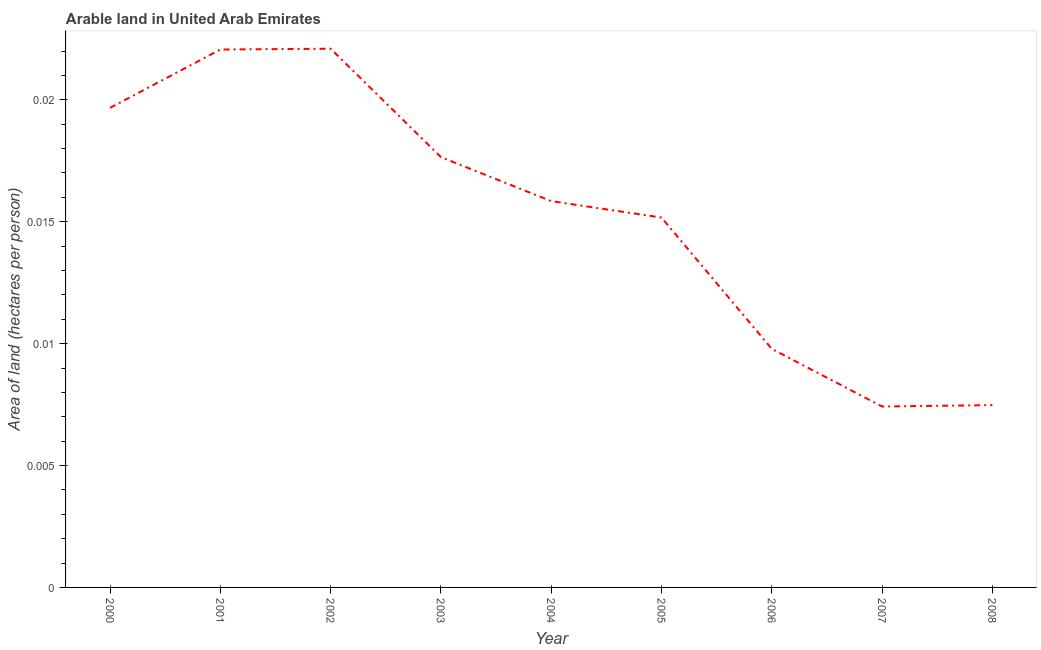What is the area of arable land in 2004?
Provide a short and direct response. 0.02. Across all years, what is the maximum area of arable land?
Make the answer very short. 0.02. Across all years, what is the minimum area of arable land?
Offer a very short reply. 0.01. In which year was the area of arable land maximum?
Give a very brief answer. 2002. In which year was the area of arable land minimum?
Your answer should be very brief. 2007. What is the sum of the area of arable land?
Your answer should be very brief. 0.14. What is the difference between the area of arable land in 2004 and 2005?
Your response must be concise. 0. What is the average area of arable land per year?
Make the answer very short. 0.02. What is the median area of arable land?
Offer a terse response. 0.02. Do a majority of the years between 2006 and 2005 (inclusive) have area of arable land greater than 0.004 hectares per person?
Make the answer very short. No. What is the ratio of the area of arable land in 2002 to that in 2005?
Your answer should be compact. 1.46. Is the area of arable land in 2001 less than that in 2007?
Your answer should be compact. No. Is the difference between the area of arable land in 2001 and 2004 greater than the difference between any two years?
Provide a short and direct response. No. What is the difference between the highest and the second highest area of arable land?
Make the answer very short. 3.310999395150088e-5. What is the difference between the highest and the lowest area of arable land?
Give a very brief answer. 0.01. In how many years, is the area of arable land greater than the average area of arable land taken over all years?
Your answer should be compact. 5. How many years are there in the graph?
Give a very brief answer. 9. What is the difference between two consecutive major ticks on the Y-axis?
Make the answer very short. 0.01. Are the values on the major ticks of Y-axis written in scientific E-notation?
Ensure brevity in your answer.  No. Does the graph contain any zero values?
Keep it short and to the point. No. What is the title of the graph?
Provide a succinct answer. Arable land in United Arab Emirates. What is the label or title of the Y-axis?
Provide a succinct answer. Area of land (hectares per person). What is the Area of land (hectares per person) in 2000?
Offer a terse response. 0.02. What is the Area of land (hectares per person) of 2001?
Make the answer very short. 0.02. What is the Area of land (hectares per person) of 2002?
Your answer should be compact. 0.02. What is the Area of land (hectares per person) of 2003?
Your response must be concise. 0.02. What is the Area of land (hectares per person) in 2004?
Your response must be concise. 0.02. What is the Area of land (hectares per person) of 2005?
Provide a succinct answer. 0.02. What is the Area of land (hectares per person) of 2006?
Your response must be concise. 0.01. What is the Area of land (hectares per person) in 2007?
Provide a short and direct response. 0.01. What is the Area of land (hectares per person) of 2008?
Provide a short and direct response. 0.01. What is the difference between the Area of land (hectares per person) in 2000 and 2001?
Provide a short and direct response. -0. What is the difference between the Area of land (hectares per person) in 2000 and 2002?
Give a very brief answer. -0. What is the difference between the Area of land (hectares per person) in 2000 and 2003?
Give a very brief answer. 0. What is the difference between the Area of land (hectares per person) in 2000 and 2004?
Your answer should be compact. 0. What is the difference between the Area of land (hectares per person) in 2000 and 2005?
Provide a short and direct response. 0. What is the difference between the Area of land (hectares per person) in 2000 and 2006?
Make the answer very short. 0.01. What is the difference between the Area of land (hectares per person) in 2000 and 2007?
Ensure brevity in your answer.  0.01. What is the difference between the Area of land (hectares per person) in 2000 and 2008?
Your answer should be very brief. 0.01. What is the difference between the Area of land (hectares per person) in 2001 and 2002?
Make the answer very short. -3e-5. What is the difference between the Area of land (hectares per person) in 2001 and 2003?
Offer a terse response. 0. What is the difference between the Area of land (hectares per person) in 2001 and 2004?
Ensure brevity in your answer.  0.01. What is the difference between the Area of land (hectares per person) in 2001 and 2005?
Your answer should be very brief. 0.01. What is the difference between the Area of land (hectares per person) in 2001 and 2006?
Provide a short and direct response. 0.01. What is the difference between the Area of land (hectares per person) in 2001 and 2007?
Your response must be concise. 0.01. What is the difference between the Area of land (hectares per person) in 2001 and 2008?
Provide a succinct answer. 0.01. What is the difference between the Area of land (hectares per person) in 2002 and 2003?
Offer a very short reply. 0. What is the difference between the Area of land (hectares per person) in 2002 and 2004?
Offer a terse response. 0.01. What is the difference between the Area of land (hectares per person) in 2002 and 2005?
Your answer should be very brief. 0.01. What is the difference between the Area of land (hectares per person) in 2002 and 2006?
Keep it short and to the point. 0.01. What is the difference between the Area of land (hectares per person) in 2002 and 2007?
Provide a succinct answer. 0.01. What is the difference between the Area of land (hectares per person) in 2002 and 2008?
Your answer should be very brief. 0.01. What is the difference between the Area of land (hectares per person) in 2003 and 2004?
Give a very brief answer. 0. What is the difference between the Area of land (hectares per person) in 2003 and 2005?
Offer a terse response. 0. What is the difference between the Area of land (hectares per person) in 2003 and 2006?
Keep it short and to the point. 0.01. What is the difference between the Area of land (hectares per person) in 2003 and 2007?
Make the answer very short. 0.01. What is the difference between the Area of land (hectares per person) in 2003 and 2008?
Provide a succinct answer. 0.01. What is the difference between the Area of land (hectares per person) in 2004 and 2005?
Keep it short and to the point. 0. What is the difference between the Area of land (hectares per person) in 2004 and 2006?
Ensure brevity in your answer.  0.01. What is the difference between the Area of land (hectares per person) in 2004 and 2007?
Provide a succinct answer. 0.01. What is the difference between the Area of land (hectares per person) in 2004 and 2008?
Your response must be concise. 0.01. What is the difference between the Area of land (hectares per person) in 2005 and 2006?
Your response must be concise. 0.01. What is the difference between the Area of land (hectares per person) in 2005 and 2007?
Make the answer very short. 0.01. What is the difference between the Area of land (hectares per person) in 2005 and 2008?
Offer a terse response. 0.01. What is the difference between the Area of land (hectares per person) in 2006 and 2007?
Your answer should be compact. 0. What is the difference between the Area of land (hectares per person) in 2006 and 2008?
Provide a short and direct response. 0. What is the difference between the Area of land (hectares per person) in 2007 and 2008?
Keep it short and to the point. -6e-5. What is the ratio of the Area of land (hectares per person) in 2000 to that in 2001?
Your answer should be very brief. 0.89. What is the ratio of the Area of land (hectares per person) in 2000 to that in 2002?
Give a very brief answer. 0.89. What is the ratio of the Area of land (hectares per person) in 2000 to that in 2003?
Provide a short and direct response. 1.11. What is the ratio of the Area of land (hectares per person) in 2000 to that in 2004?
Provide a short and direct response. 1.24. What is the ratio of the Area of land (hectares per person) in 2000 to that in 2005?
Ensure brevity in your answer.  1.3. What is the ratio of the Area of land (hectares per person) in 2000 to that in 2006?
Your answer should be compact. 2.01. What is the ratio of the Area of land (hectares per person) in 2000 to that in 2007?
Offer a very short reply. 2.65. What is the ratio of the Area of land (hectares per person) in 2000 to that in 2008?
Provide a succinct answer. 2.63. What is the ratio of the Area of land (hectares per person) in 2001 to that in 2002?
Give a very brief answer. 1. What is the ratio of the Area of land (hectares per person) in 2001 to that in 2003?
Your answer should be compact. 1.25. What is the ratio of the Area of land (hectares per person) in 2001 to that in 2004?
Your response must be concise. 1.39. What is the ratio of the Area of land (hectares per person) in 2001 to that in 2005?
Offer a very short reply. 1.45. What is the ratio of the Area of land (hectares per person) in 2001 to that in 2006?
Your response must be concise. 2.25. What is the ratio of the Area of land (hectares per person) in 2001 to that in 2007?
Your response must be concise. 2.97. What is the ratio of the Area of land (hectares per person) in 2001 to that in 2008?
Keep it short and to the point. 2.95. What is the ratio of the Area of land (hectares per person) in 2002 to that in 2003?
Your answer should be compact. 1.25. What is the ratio of the Area of land (hectares per person) in 2002 to that in 2004?
Provide a succinct answer. 1.4. What is the ratio of the Area of land (hectares per person) in 2002 to that in 2005?
Your answer should be very brief. 1.46. What is the ratio of the Area of land (hectares per person) in 2002 to that in 2006?
Keep it short and to the point. 2.26. What is the ratio of the Area of land (hectares per person) in 2002 to that in 2007?
Keep it short and to the point. 2.98. What is the ratio of the Area of land (hectares per person) in 2002 to that in 2008?
Your answer should be compact. 2.96. What is the ratio of the Area of land (hectares per person) in 2003 to that in 2004?
Your answer should be very brief. 1.11. What is the ratio of the Area of land (hectares per person) in 2003 to that in 2005?
Offer a terse response. 1.16. What is the ratio of the Area of land (hectares per person) in 2003 to that in 2006?
Your response must be concise. 1.8. What is the ratio of the Area of land (hectares per person) in 2003 to that in 2007?
Offer a terse response. 2.38. What is the ratio of the Area of land (hectares per person) in 2003 to that in 2008?
Your answer should be very brief. 2.36. What is the ratio of the Area of land (hectares per person) in 2004 to that in 2005?
Keep it short and to the point. 1.04. What is the ratio of the Area of land (hectares per person) in 2004 to that in 2006?
Your response must be concise. 1.62. What is the ratio of the Area of land (hectares per person) in 2004 to that in 2007?
Provide a succinct answer. 2.13. What is the ratio of the Area of land (hectares per person) in 2004 to that in 2008?
Your answer should be very brief. 2.12. What is the ratio of the Area of land (hectares per person) in 2005 to that in 2006?
Keep it short and to the point. 1.55. What is the ratio of the Area of land (hectares per person) in 2005 to that in 2007?
Offer a terse response. 2.04. What is the ratio of the Area of land (hectares per person) in 2005 to that in 2008?
Offer a terse response. 2.03. What is the ratio of the Area of land (hectares per person) in 2006 to that in 2007?
Your answer should be compact. 1.32. What is the ratio of the Area of land (hectares per person) in 2006 to that in 2008?
Ensure brevity in your answer.  1.31. 